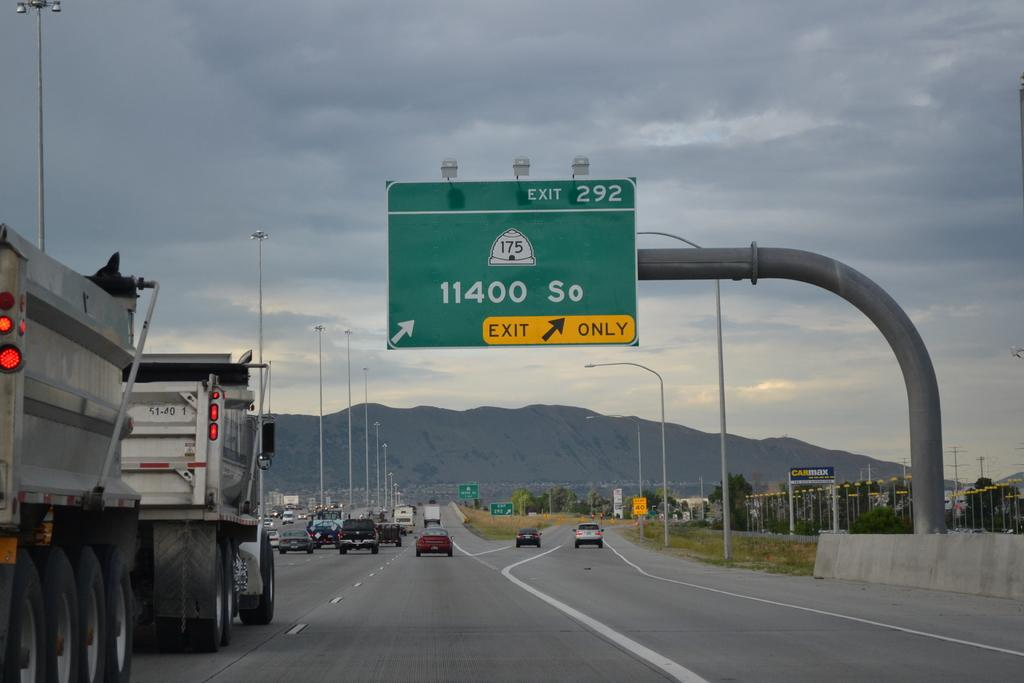Provide a one-sentence caption for the provided image. An exit sign on a highway for exit 292 is hanging overhead. 